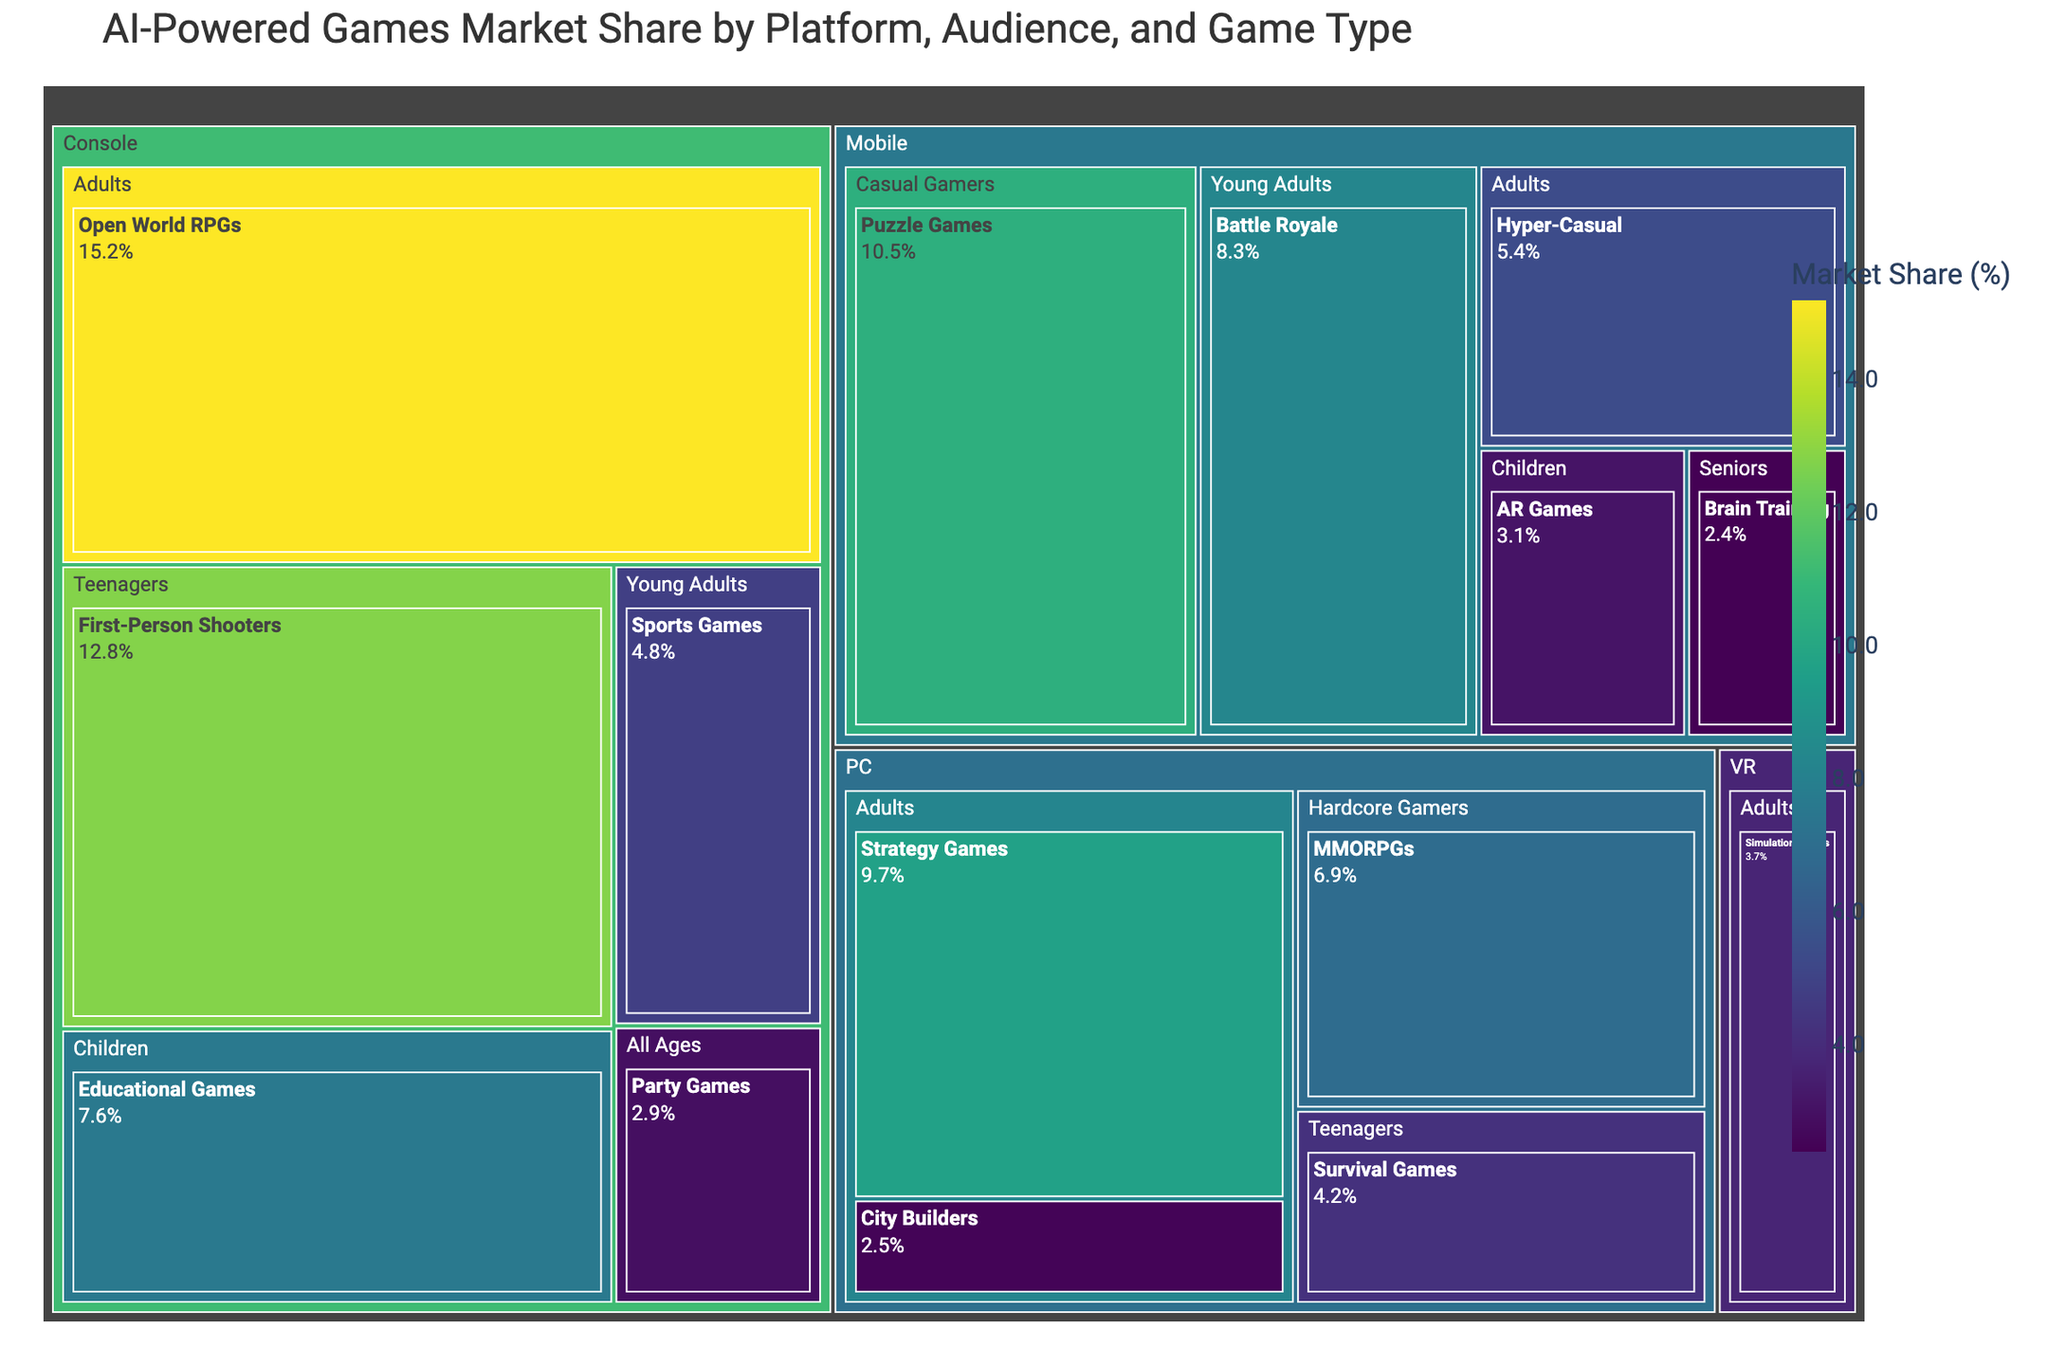What is the title of the treemap? The title is displayed at the top of the treemap, usually in a larger and bold font.
Answer: AI-Powered Games Market Share by Platform, Audience, and Game Type Which game type has the largest market share on the Console platform? Look for the Console segment and identify the game type with the largest market share within it.
Answer: Open World RPGs What is the combined market share of Puzzle Games and Hyper-Casual games on the Mobile platform? Find the market share of both Puzzle Games and Hyper-Casual games under the Mobile platform and sum them up: 10.5% + 5.4% = 15.9%
Answer: 15.9% Which target audience has the smallest market share within the PC platform? Find the different target audiences within the PC platform and identify the one with the smallest market share.
Answer: Adults (City Builders, 2.5%) How does the market share of Battle Royale games on Mobile compare to the market share of Simulation Games on VR? Find the market shares for both Battle Royale games on Mobile and Simulation Games on VR and compare them: 8.3% vs 3.7%.
Answer: Battle Royale games have a larger market share Which platform has the most diverse target audiences represented? Count the number of different target audiences within each platform and identify the one with the most variety.
Answer: Mobile What is the market share of games targeting Children on the Console platform? Locate the segment for Children under Console and find its market share.
Answer: 7.6% What is the total market share of games targeting Adults across all platforms? Sum the market shares of Adult target audience across all platforms: 15.2% (Console) + 9.7% (PC) + 5.4% (Mobile) + 3.7% (VR) = 34.0%
Answer: 34.0% Compare the market share of First-Person Shooters aimed at Teenagers on the Console platform to Survival Games aimed at Teenagers on the PC platform. Which one is larger? Find the market shares for both game types in their respective segments and compare them: 12.8% (First-Person Shooters, Console) vs 4.2% (Survival Games, PC).
Answer: First-Person Shooters (Console) What is the difference between the market share of Battle Royale games targeting Young Adults on Mobile and Party Games targeting All Ages on the Console? Subtract the market share of Party Games from Battle Royale games: 8.3% - 2.9% = 5.4%.
Answer: 5.4% 